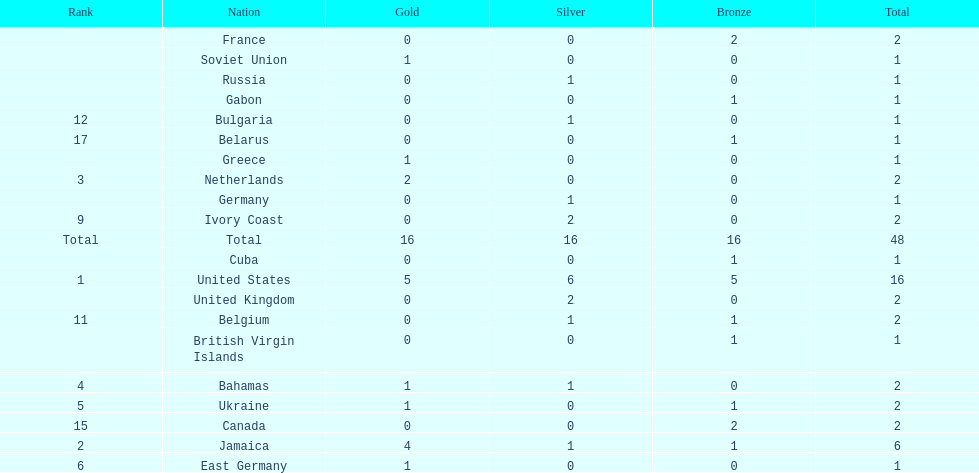What is the total number of gold medals won by jamaica? 4. Parse the table in full. {'header': ['Rank', 'Nation', 'Gold', 'Silver', 'Bronze', 'Total'], 'rows': [['', 'France', '0', '0', '2', '2'], ['', 'Soviet Union', '1', '0', '0', '1'], ['', 'Russia', '0', '1', '0', '1'], ['', 'Gabon', '0', '0', '1', '1'], ['12', 'Bulgaria', '0', '1', '0', '1'], ['17', 'Belarus', '0', '0', '1', '1'], ['', 'Greece', '1', '0', '0', '1'], ['3', 'Netherlands', '2', '0', '0', '2'], ['', 'Germany', '0', '1', '0', '1'], ['9', 'Ivory Coast', '0', '2', '0', '2'], ['Total', 'Total', '16', '16', '16', '48'], ['', 'Cuba', '0', '0', '1', '1'], ['1', 'United States', '5', '6', '5', '16'], ['', 'United Kingdom', '0', '2', '0', '2'], ['11', 'Belgium', '0', '1', '1', '2'], ['', 'British Virgin Islands', '0', '0', '1', '1'], ['4', 'Bahamas', '1', '1', '0', '2'], ['5', 'Ukraine', '1', '0', '1', '2'], ['15', 'Canada', '0', '0', '2', '2'], ['2', 'Jamaica', '4', '1', '1', '6'], ['6', 'East Germany', '1', '0', '0', '1']]} 